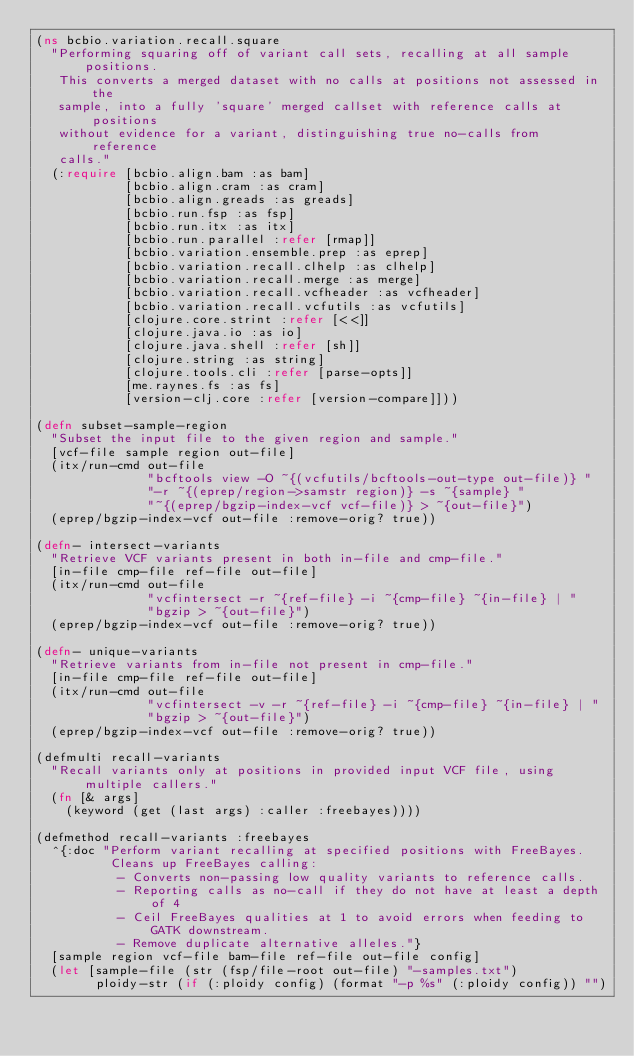Convert code to text. <code><loc_0><loc_0><loc_500><loc_500><_Clojure_>(ns bcbio.variation.recall.square
  "Performing squaring off of variant call sets, recalling at all sample positions.
   This converts a merged dataset with no calls at positions not assessed in the
   sample, into a fully 'square' merged callset with reference calls at positions
   without evidence for a variant, distinguishing true no-calls from reference
   calls."
  (:require [bcbio.align.bam :as bam]
            [bcbio.align.cram :as cram]
            [bcbio.align.greads :as greads]
            [bcbio.run.fsp :as fsp]
            [bcbio.run.itx :as itx]
            [bcbio.run.parallel :refer [rmap]]
            [bcbio.variation.ensemble.prep :as eprep]
            [bcbio.variation.recall.clhelp :as clhelp]
            [bcbio.variation.recall.merge :as merge]
            [bcbio.variation.recall.vcfheader :as vcfheader]
            [bcbio.variation.recall.vcfutils :as vcfutils]
            [clojure.core.strint :refer [<<]]
            [clojure.java.io :as io]
            [clojure.java.shell :refer [sh]]
            [clojure.string :as string]
            [clojure.tools.cli :refer [parse-opts]]
            [me.raynes.fs :as fs]
            [version-clj.core :refer [version-compare]]))

(defn subset-sample-region
  "Subset the input file to the given region and sample."
  [vcf-file sample region out-file]
  (itx/run-cmd out-file
               "bcftools view -O ~{(vcfutils/bcftools-out-type out-file)} "
               "-r ~{(eprep/region->samstr region)} -s ~{sample} "
               "~{(eprep/bgzip-index-vcf vcf-file)} > ~{out-file}")
  (eprep/bgzip-index-vcf out-file :remove-orig? true))

(defn- intersect-variants
  "Retrieve VCF variants present in both in-file and cmp-file."
  [in-file cmp-file ref-file out-file]
  (itx/run-cmd out-file
               "vcfintersect -r ~{ref-file} -i ~{cmp-file} ~{in-file} | "
               "bgzip > ~{out-file}")
  (eprep/bgzip-index-vcf out-file :remove-orig? true))

(defn- unique-variants
  "Retrieve variants from in-file not present in cmp-file."
  [in-file cmp-file ref-file out-file]
  (itx/run-cmd out-file
               "vcfintersect -v -r ~{ref-file} -i ~{cmp-file} ~{in-file} | "
               "bgzip > ~{out-file}")
  (eprep/bgzip-index-vcf out-file :remove-orig? true))

(defmulti recall-variants
  "Recall variants only at positions in provided input VCF file, using multiple callers."
  (fn [& args]
    (keyword (get (last args) :caller :freebayes))))

(defmethod recall-variants :freebayes
  ^{:doc "Perform variant recalling at specified positions with FreeBayes.
          Cleans up FreeBayes calling:
           - Converts non-passing low quality variants to reference calls.
           - Reporting calls as no-call if they do not have at least a depth of 4
           - Ceil FreeBayes qualities at 1 to avoid errors when feeding to GATK downstream.
           - Remove duplicate alternative alleles."}
  [sample region vcf-file bam-file ref-file out-file config]
  (let [sample-file (str (fsp/file-root out-file) "-samples.txt")
        ploidy-str (if (:ploidy config) (format "-p %s" (:ploidy config)) "")</code> 